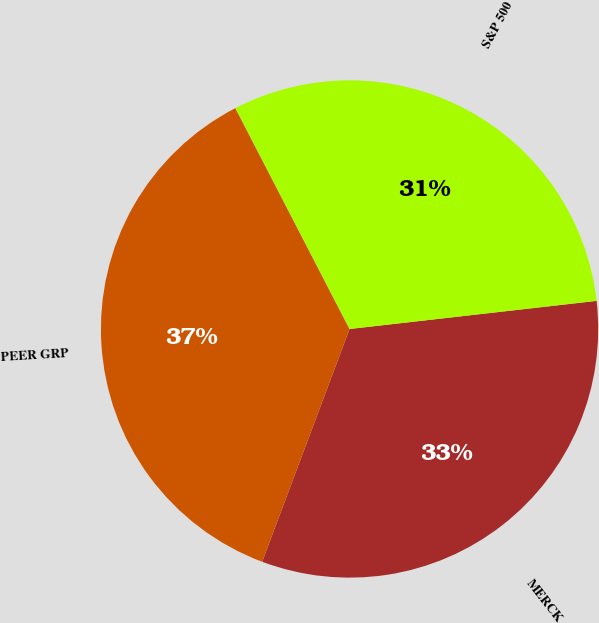Convert chart. <chart><loc_0><loc_0><loc_500><loc_500><pie_chart><fcel>MERCK<fcel>PEER GRP<fcel>S&P 500<nl><fcel>32.52%<fcel>36.69%<fcel>30.79%<nl></chart> 